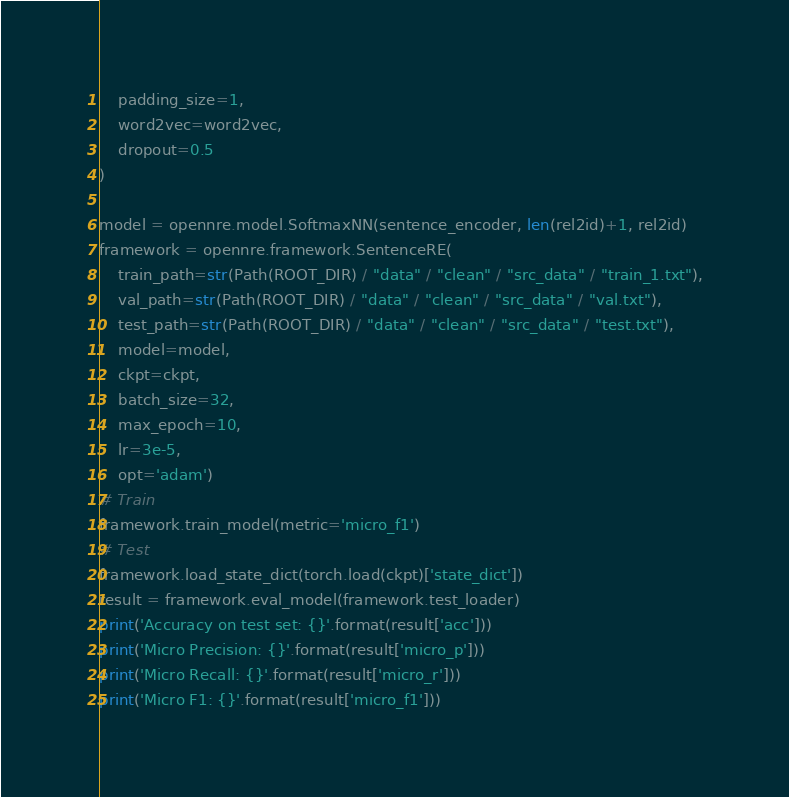<code> <loc_0><loc_0><loc_500><loc_500><_Python_>    padding_size=1,
    word2vec=word2vec,
    dropout=0.5
)

model = opennre.model.SoftmaxNN(sentence_encoder, len(rel2id)+1, rel2id)
framework = opennre.framework.SentenceRE(
    train_path=str(Path(ROOT_DIR) / "data" / "clean" / "src_data" / "train_1.txt"),
    val_path=str(Path(ROOT_DIR) / "data" / "clean" / "src_data" / "val.txt"),
    test_path=str(Path(ROOT_DIR) / "data" / "clean" / "src_data" / "test.txt"),
    model=model,
    ckpt=ckpt,
    batch_size=32,
    max_epoch=10,
    lr=3e-5,
    opt='adam')
# Train
framework.train_model(metric='micro_f1')
# Test
framework.load_state_dict(torch.load(ckpt)['state_dict'])
result = framework.eval_model(framework.test_loader)
print('Accuracy on test set: {}'.format(result['acc']))
print('Micro Precision: {}'.format(result['micro_p']))
print('Micro Recall: {}'.format(result['micro_r']))
print('Micro F1: {}'.format(result['micro_f1']))
</code> 